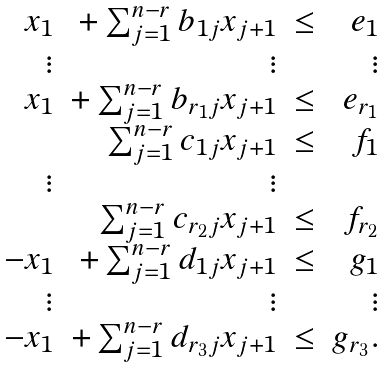Convert formula to latex. <formula><loc_0><loc_0><loc_500><loc_500>\begin{array} { r r r r } x _ { 1 } & + \sum _ { j = 1 } ^ { n - r } b _ { 1 j } x _ { j + 1 } & \leq & e _ { 1 } \\ \vdots & \vdots & & \vdots \\ x _ { 1 } & + \sum _ { j = 1 } ^ { n - r } b _ { r _ { 1 } j } x _ { j + 1 } & \leq & e _ { r _ { 1 } } \\ & \sum _ { j = 1 } ^ { n - r } c _ { 1 j } x _ { j + 1 } & \leq & f _ { 1 } \\ \vdots & \vdots & & \\ & \sum _ { j = 1 } ^ { n - r } c _ { r _ { 2 } j } x _ { j + 1 } & \leq & f _ { r _ { 2 } } \\ - x _ { 1 } & + \sum _ { j = 1 } ^ { n - r } d _ { 1 j } x _ { j + 1 } & \leq & g _ { 1 } \\ \vdots & \vdots & & \vdots \\ - x _ { 1 } & + \sum _ { j = 1 } ^ { n - r } d _ { r _ { 3 } j } x _ { j + 1 } & \leq & g _ { r _ { 3 } } . \end{array}</formula> 